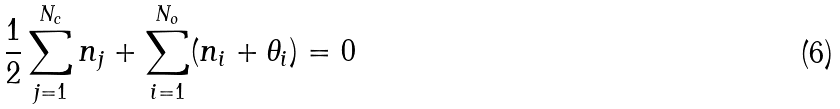<formula> <loc_0><loc_0><loc_500><loc_500>\frac { 1 } { 2 } \sum _ { j = 1 } ^ { N _ { c } } n _ { j } + \sum _ { i = 1 } ^ { N _ { o } } ( n _ { i } + \theta _ { i } ) = 0</formula> 